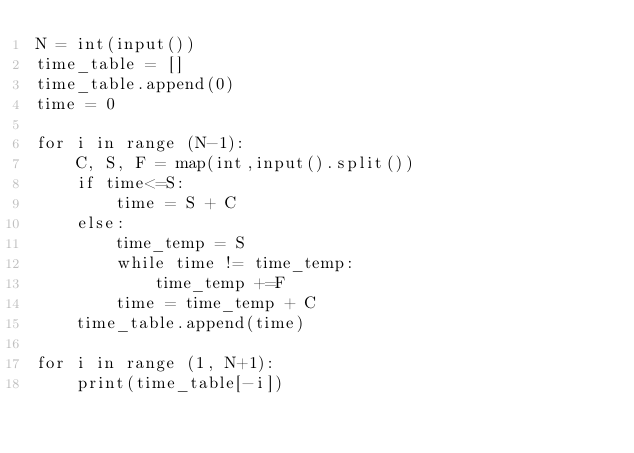<code> <loc_0><loc_0><loc_500><loc_500><_Python_>N = int(input())
time_table = []
time_table.append(0)
time = 0

for i in range (N-1):
    C, S, F = map(int,input().split())
    if time<=S:
        time = S + C
    else:
        time_temp = S
        while time != time_temp:
            time_temp +=F
        time = time_temp + C
    time_table.append(time)

for i in range (1, N+1):
    print(time_table[-i])
</code> 